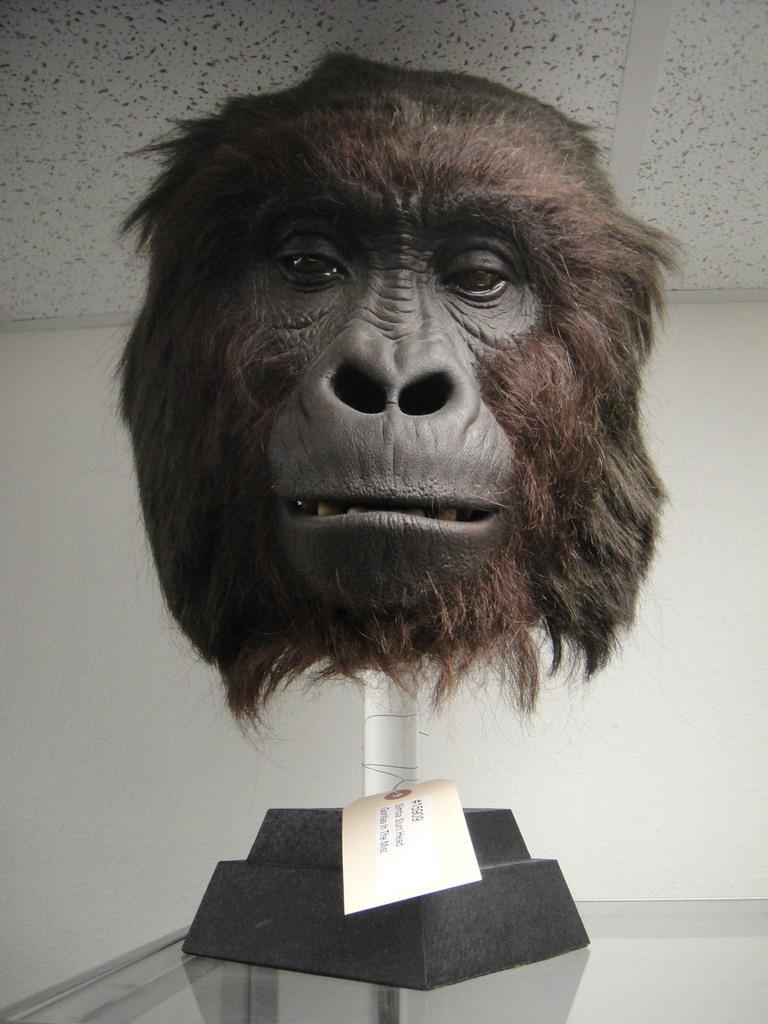Can you describe this image briefly? In the center of the image there is a head of a chimpanzee. In the background of the image there is wall. At the bottom of the image there is glass. 